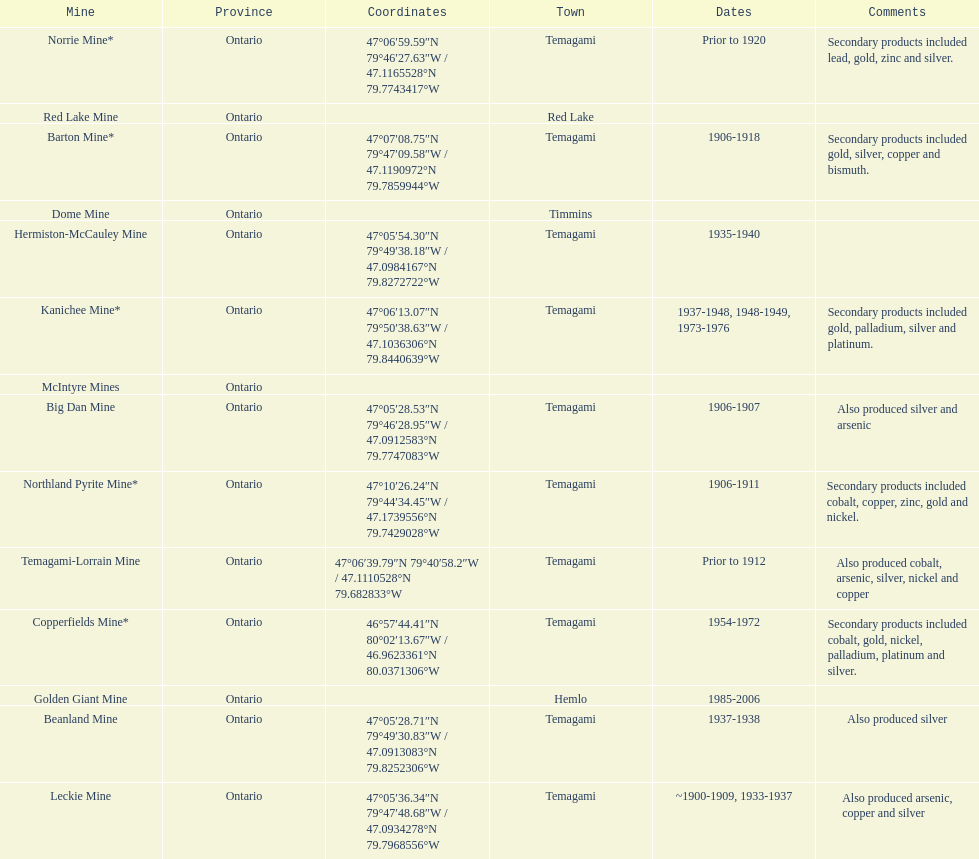In what mine could you find bismuth? Barton Mine. I'm looking to parse the entire table for insights. Could you assist me with that? {'header': ['Mine', 'Province', 'Coordinates', 'Town', 'Dates', 'Comments'], 'rows': [['Norrie Mine*', 'Ontario', '47°06′59.59″N 79°46′27.63″W\ufeff / \ufeff47.1165528°N 79.7743417°W', 'Temagami', 'Prior to 1920', 'Secondary products included lead, gold, zinc and silver.'], ['Red Lake Mine', 'Ontario', '', 'Red Lake', '', ''], ['Barton Mine*', 'Ontario', '47°07′08.75″N 79°47′09.58″W\ufeff / \ufeff47.1190972°N 79.7859944°W', 'Temagami', '1906-1918', 'Secondary products included gold, silver, copper and bismuth.'], ['Dome Mine', 'Ontario', '', 'Timmins', '', ''], ['Hermiston-McCauley Mine', 'Ontario', '47°05′54.30″N 79°49′38.18″W\ufeff / \ufeff47.0984167°N 79.8272722°W', 'Temagami', '1935-1940', ''], ['Kanichee Mine*', 'Ontario', '47°06′13.07″N 79°50′38.63″W\ufeff / \ufeff47.1036306°N 79.8440639°W', 'Temagami', '1937-1948, 1948-1949, 1973-1976', 'Secondary products included gold, palladium, silver and platinum.'], ['McIntyre Mines', 'Ontario', '', '', '', ''], ['Big Dan Mine', 'Ontario', '47°05′28.53″N 79°46′28.95″W\ufeff / \ufeff47.0912583°N 79.7747083°W', 'Temagami', '1906-1907', 'Also produced silver and arsenic'], ['Northland Pyrite Mine*', 'Ontario', '47°10′26.24″N 79°44′34.45″W\ufeff / \ufeff47.1739556°N 79.7429028°W', 'Temagami', '1906-1911', 'Secondary products included cobalt, copper, zinc, gold and nickel.'], ['Temagami-Lorrain Mine', 'Ontario', '47°06′39.79″N 79°40′58.2″W\ufeff / \ufeff47.1110528°N 79.682833°W', 'Temagami', 'Prior to 1912', 'Also produced cobalt, arsenic, silver, nickel and copper'], ['Copperfields Mine*', 'Ontario', '46°57′44.41″N 80°02′13.67″W\ufeff / \ufeff46.9623361°N 80.0371306°W', 'Temagami', '1954-1972', 'Secondary products included cobalt, gold, nickel, palladium, platinum and silver.'], ['Golden Giant Mine', 'Ontario', '', 'Hemlo', '1985-2006', ''], ['Beanland Mine', 'Ontario', '47°05′28.71″N 79°49′30.83″W\ufeff / \ufeff47.0913083°N 79.8252306°W', 'Temagami', '1937-1938', 'Also produced silver'], ['Leckie Mine', 'Ontario', '47°05′36.34″N 79°47′48.68″W\ufeff / \ufeff47.0934278°N 79.7968556°W', 'Temagami', '~1900-1909, 1933-1937', 'Also produced arsenic, copper and silver']]} 